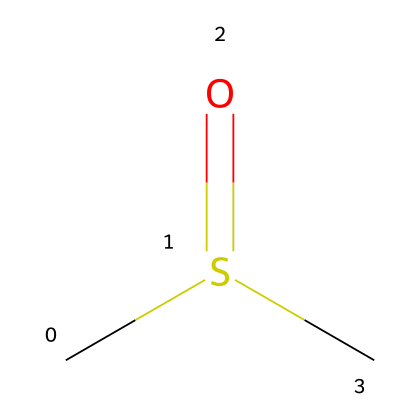What is the molecular formula of DMSO? The molecular formula can be deduced from the SMILES representation. From the SMILES "CS(=O)C", we identify one carbon (C) bonded to another carbon (C), with a sulfur (S) that has a double bond to an oxygen (O) and a single bond to the other carbon. Therefore, the molecular formula is C2H6OS.
Answer: C2H6OS How many oxygen atoms are present in DMSO? In the SMILES representation, you can identify there is one "O" that is attached to sulfur and one oxygen atom that forms a double bond with sulfur. This indicates that there is a total of one oxygen atom in the molecule.
Answer: 1 What type of functional group is present in DMSO? The structure features a sulfur atom double bonded to an oxygen atom, which indicates the presence of a sulfoxide functional group. This characteristic defines DMSO as a sulfoxide.
Answer: sulfoxide What is the total number of hydrogen atoms in DMSO? By analyzing the SMILES representation "CS(=O)C", we identify that there are six hydrogen atoms connected to the two carbon atoms, as there are no hydrogen atoms directly bonded to the sulfur or oxygen atoms. Thus, the total number is six.
Answer: 6 Is DMSO polar or nonpolar? Given the presence of the oxygen and sulfur atoms, which have different electronegativities compared to carbon and hydrogen, this results in a net dipole moment in the molecule. Therefore, it indicates that DMSO is polar.
Answer: polar How many carbon atoms are found in DMSO? The SMILES notation "CS(=O)C" shows two "C" entries, indicating that there are two carbon atoms present in the structure of the compound.
Answer: 2 